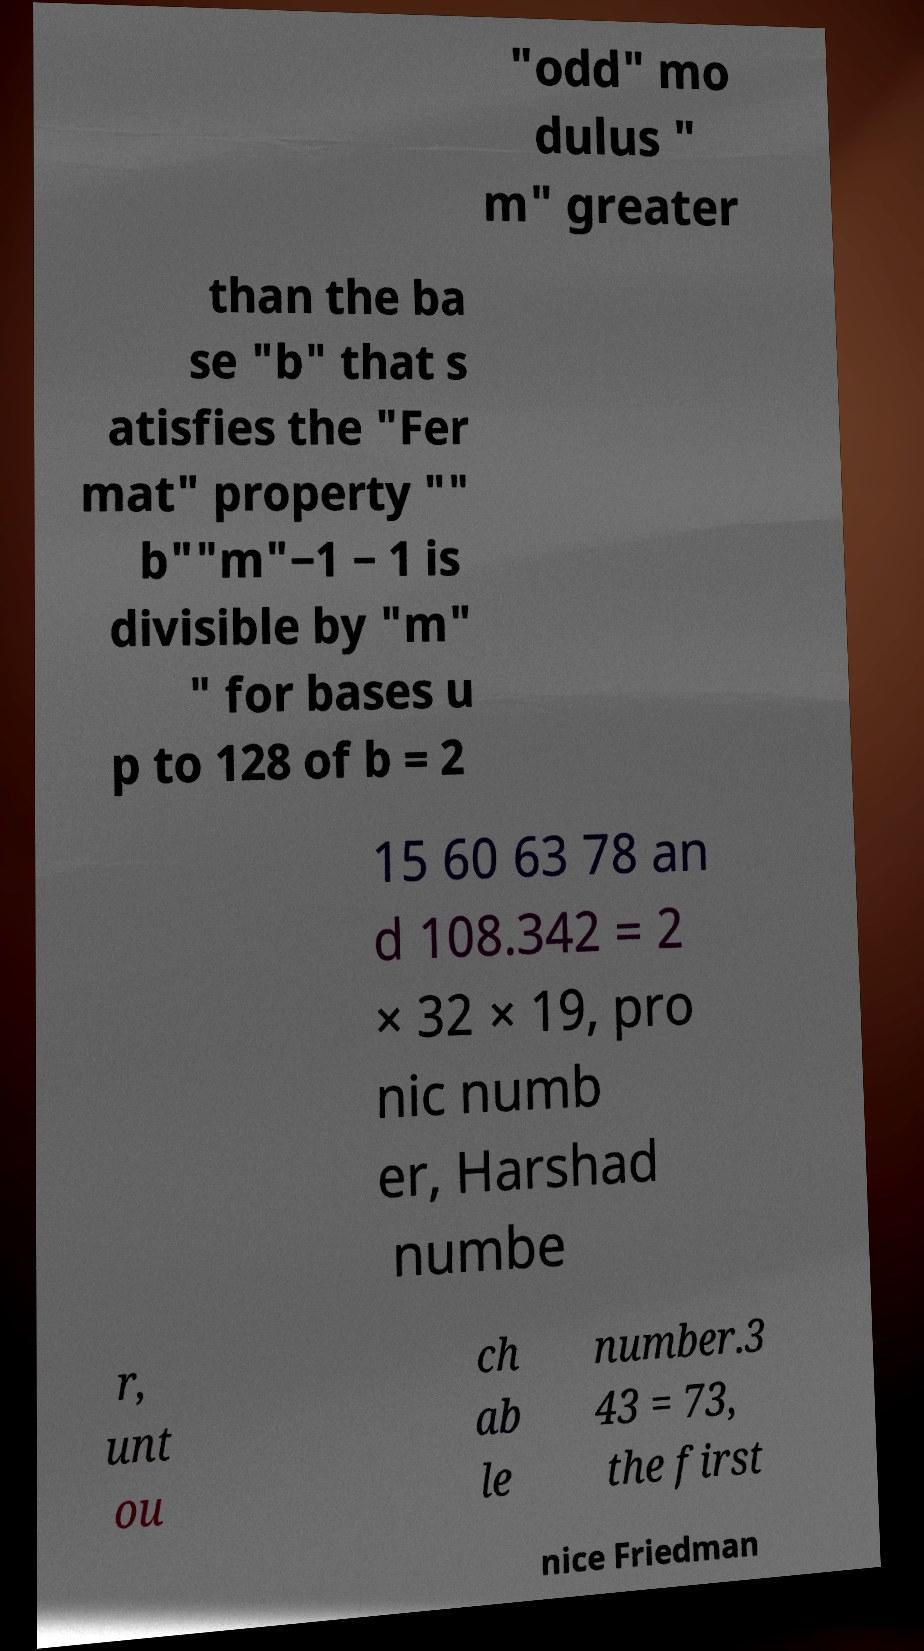For documentation purposes, I need the text within this image transcribed. Could you provide that? "odd" mo dulus " m" greater than the ba se "b" that s atisfies the "Fer mat" property "" b""m"−1 − 1 is divisible by "m" " for bases u p to 128 of b = 2 15 60 63 78 an d 108.342 = 2 × 32 × 19, pro nic numb er, Harshad numbe r, unt ou ch ab le number.3 43 = 73, the first nice Friedman 